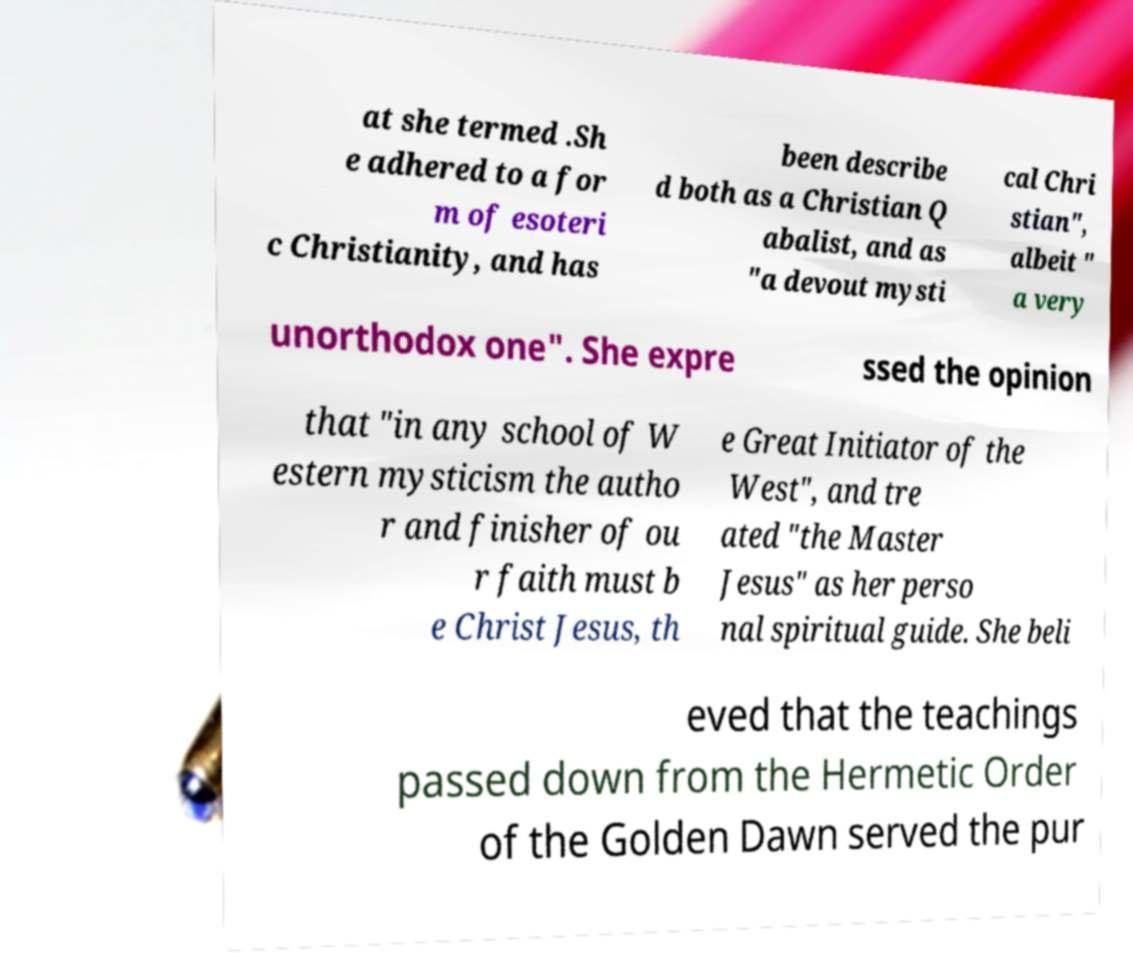Can you read and provide the text displayed in the image?This photo seems to have some interesting text. Can you extract and type it out for me? at she termed .Sh e adhered to a for m of esoteri c Christianity, and has been describe d both as a Christian Q abalist, and as "a devout mysti cal Chri stian", albeit " a very unorthodox one". She expre ssed the opinion that "in any school of W estern mysticism the autho r and finisher of ou r faith must b e Christ Jesus, th e Great Initiator of the West", and tre ated "the Master Jesus" as her perso nal spiritual guide. She beli eved that the teachings passed down from the Hermetic Order of the Golden Dawn served the pur 